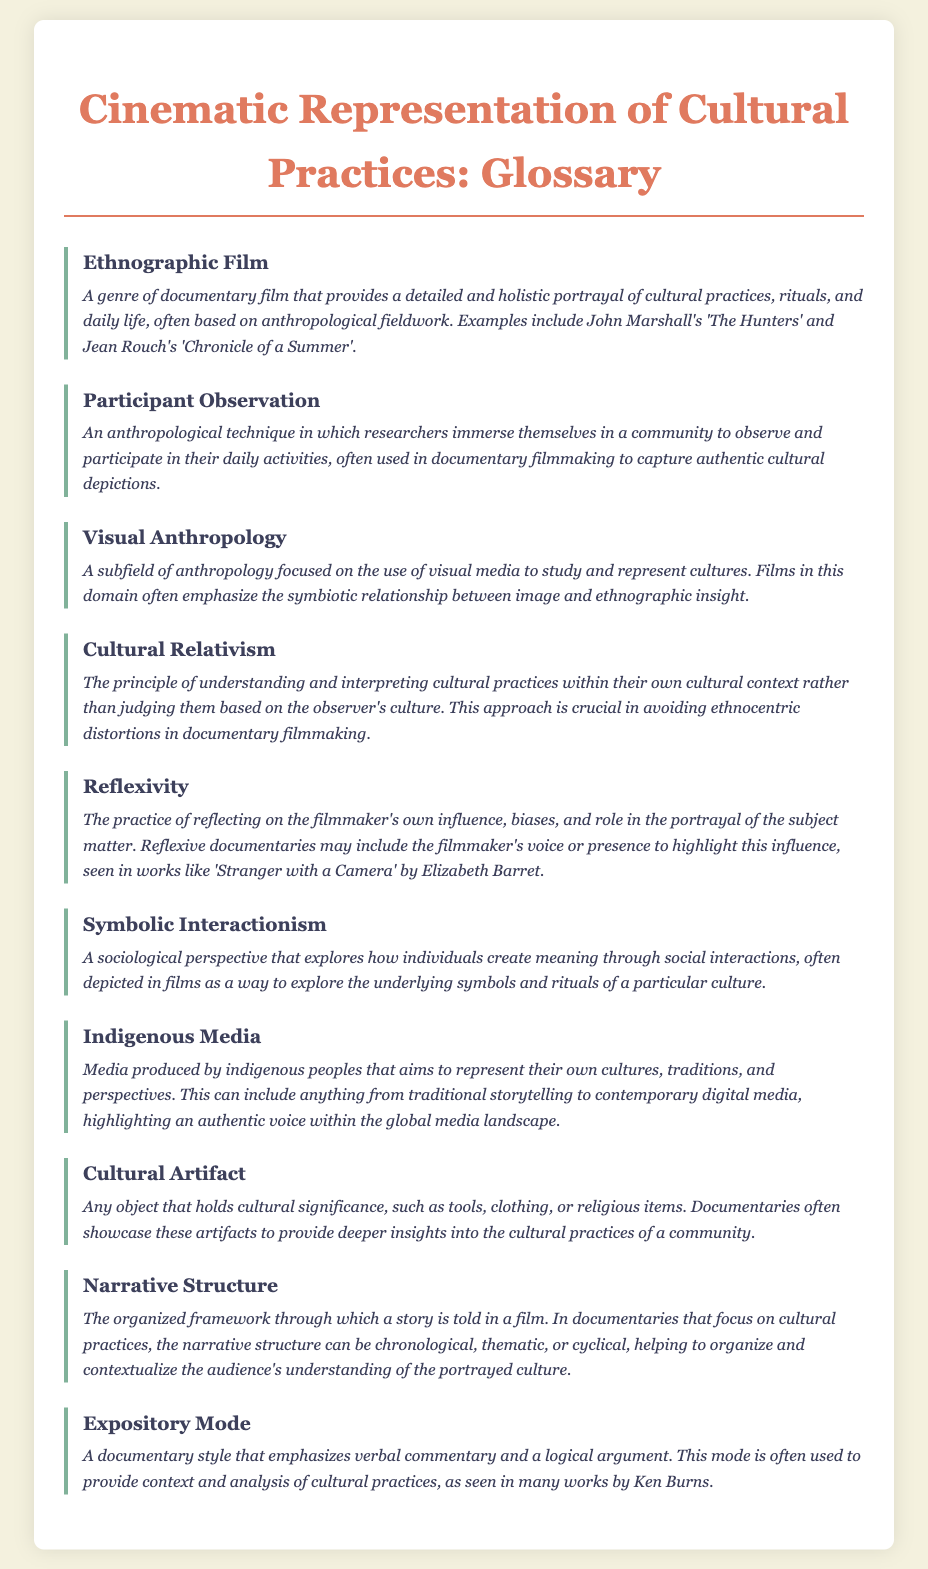what is ethnographic film? Ethnographic film is defined as a genre of documentary film that provides a detailed and holistic portrayal of cultural practices, rituals, and daily life, often based on anthropological fieldwork.
Answer: A genre of documentary film who are two filmmakers associated with ethnographic film? The document lists John Marshall and Jean Rouch as examples of filmmakers in the ethnographic film genre.
Answer: John Marshall and Jean Rouch what does participant observation involve? Participant observation is described as an anthropological technique in which researchers immerse themselves in a community to observe and participate in their daily activities.
Answer: Immersion in a community what is a key principle of cultural relativism? Cultural relativism is centered on the principle of understanding and interpreting cultural practices within their own cultural context.
Answer: Understanding within own context what documentary exemplifies reflexivity? 'Stranger with a Camera' by Elizabeth Barret is mentioned as an example of a reflexive documentary.
Answer: Stranger with a Camera how is narrative structure relevant to documentaries? The definition explains narrative structure as the organized framework through which a story is told in a film, organizing and contextualizing understanding of culture.
Answer: Framework of storytelling what is an example of indigenous media? Indigenous media can include anything from traditional storytelling to contemporary digital media that represents indigenous peoples.
Answer: Traditional storytelling to digital media 